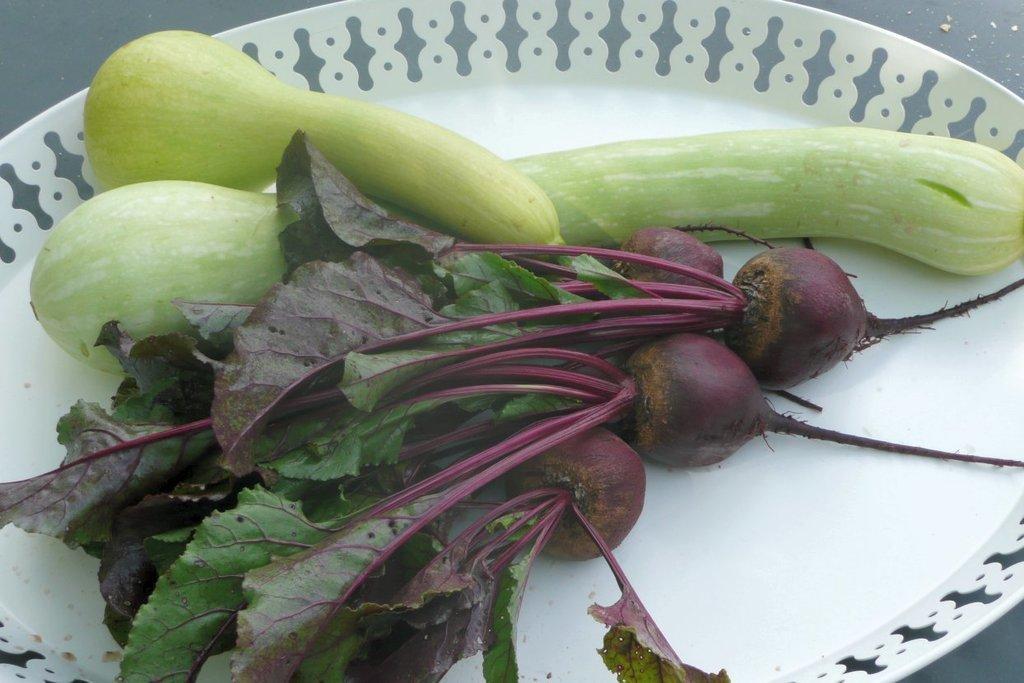Please provide a concise description of this image. In this image we can see different types of vegetables on a white plate. 